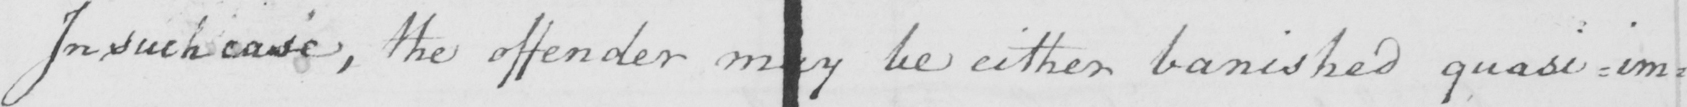What text is written in this handwritten line? In such case , the offender may be either banished quasi-imp= 